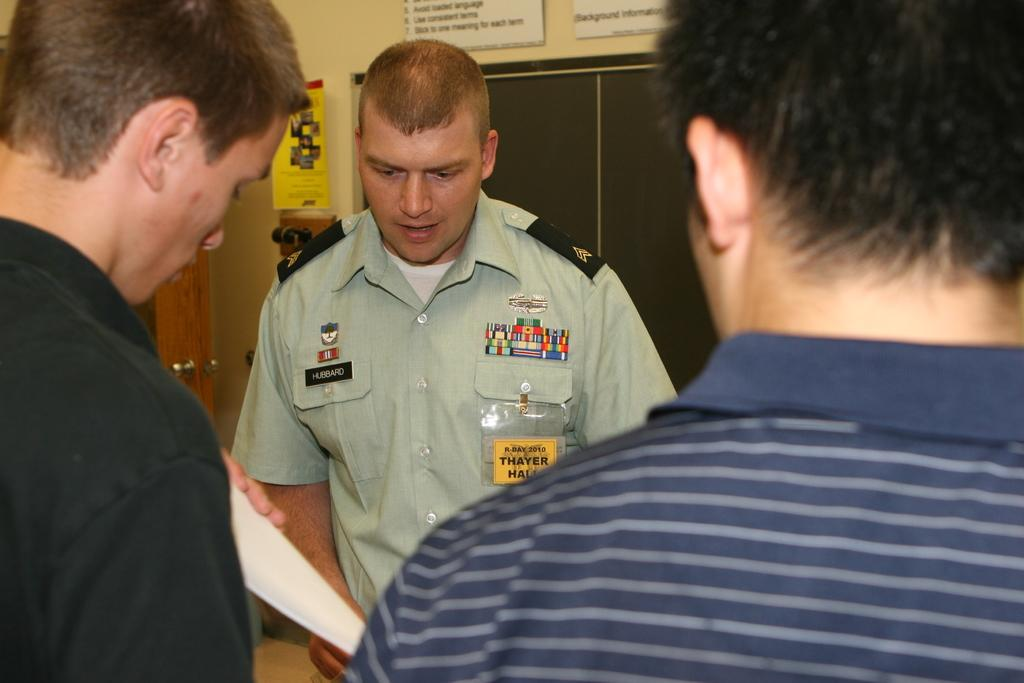How many people are in the image? There are three persons in the image. What can be observed about their clothing? The persons are wearing different color dresses. Where are the persons standing in the image? The persons are standing on the floor. What can be seen on the wall in the background? There are posters on the wall in the background. What is located near the posters? There is a door near the posters. What type of net is being used by the persons in the image? There is no net present in the image; the persons are simply standing on the floor. Are the persons wearing stockings in the image? The provided facts do not mention anything about stockings, so it cannot be determined from the image. 